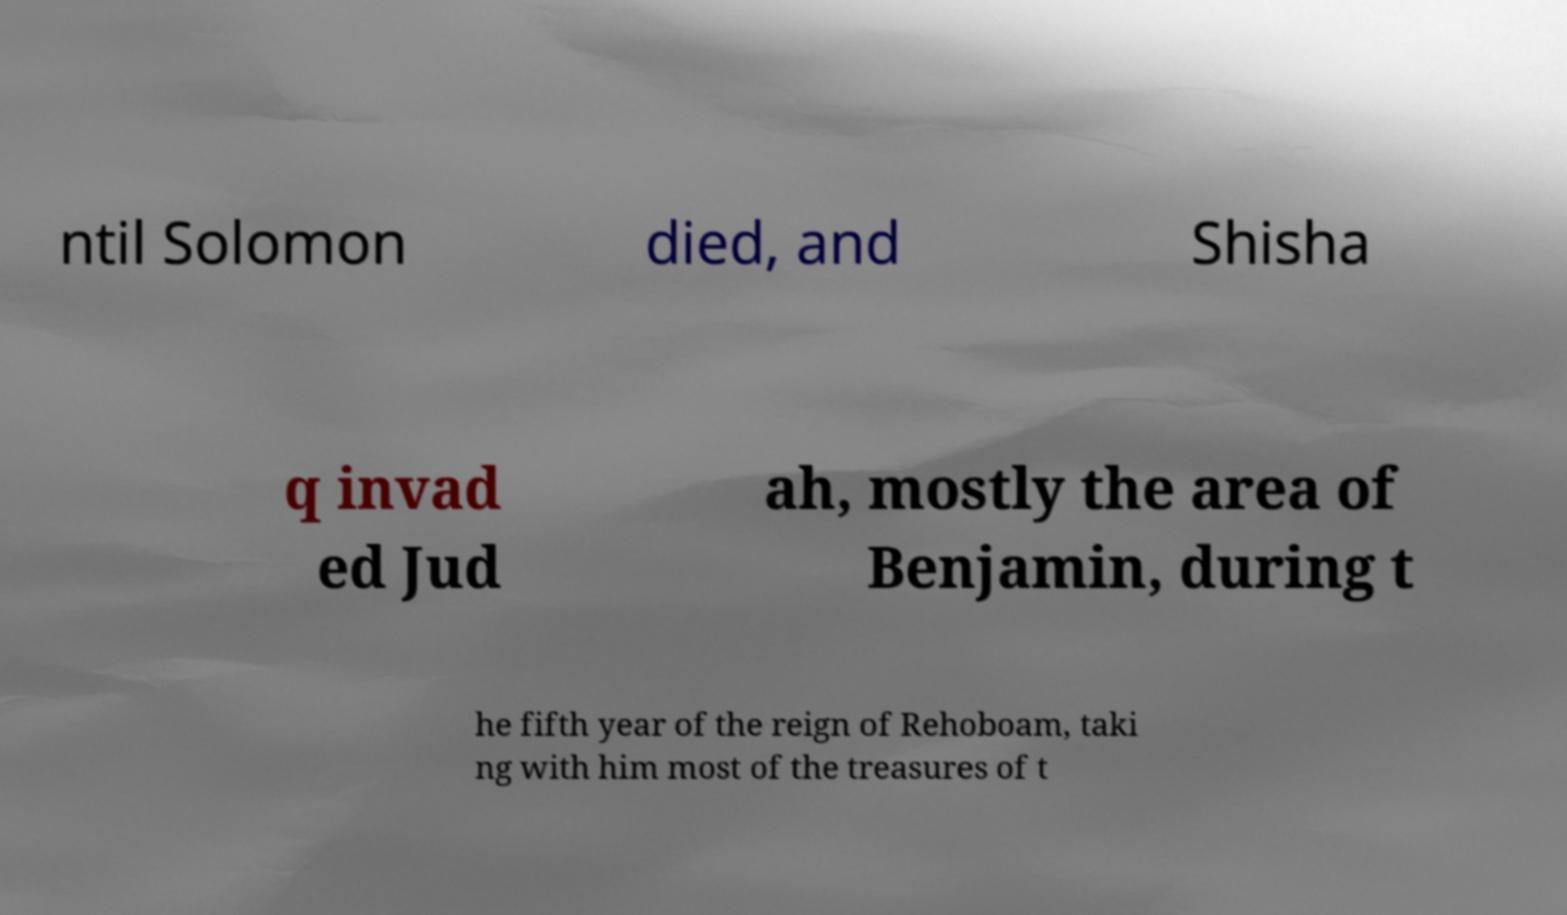Can you read and provide the text displayed in the image?This photo seems to have some interesting text. Can you extract and type it out for me? ntil Solomon died, and Shisha q invad ed Jud ah, mostly the area of Benjamin, during t he fifth year of the reign of Rehoboam, taki ng with him most of the treasures of t 